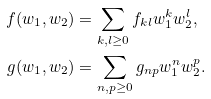Convert formula to latex. <formula><loc_0><loc_0><loc_500><loc_500>f ( w _ { 1 } , w _ { 2 } ) & = \sum _ { k , l \geq 0 } f _ { k l } w _ { 1 } ^ { k } w _ { 2 } ^ { l } , \\ g ( w _ { 1 } , w _ { 2 } ) & = \sum _ { n , p \geq 0 } g _ { n p } w _ { 1 } ^ { n } w _ { 2 } ^ { p } .</formula> 